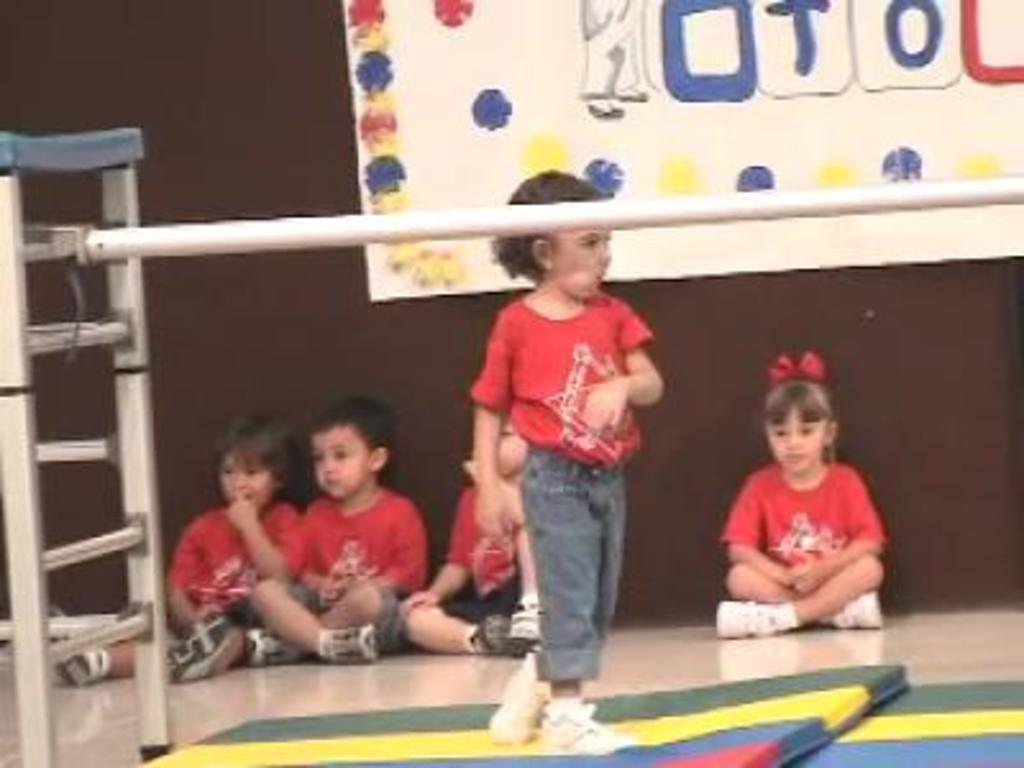What types of people are in the image? There are children in the image. Can you describe the girl among the children? One girl is standing among the children. What can be seen in the background of the image? There is a board visible in the background of the image. What type of lunchroom is depicted in the image? There is no lunchroom present in the image; it features children and a board in the background. What is the girl's mother doing in the image? There is no mother present in the image, so it is not possible to determine what she might be doing. 